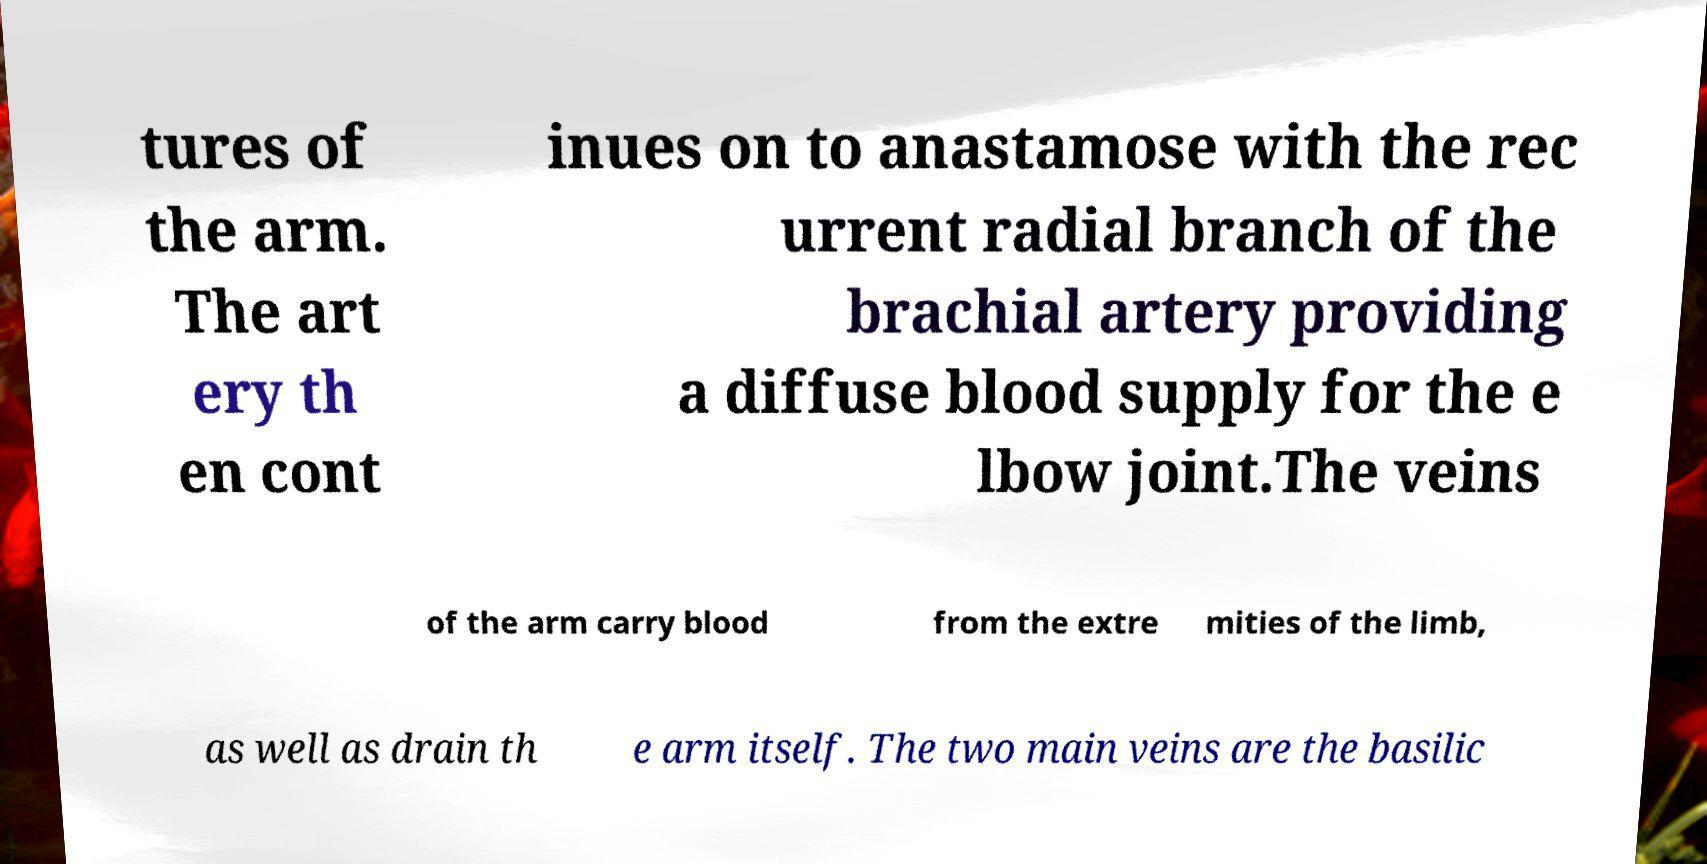Can you read and provide the text displayed in the image?This photo seems to have some interesting text. Can you extract and type it out for me? tures of the arm. The art ery th en cont inues on to anastamose with the rec urrent radial branch of the brachial artery providing a diffuse blood supply for the e lbow joint.The veins of the arm carry blood from the extre mities of the limb, as well as drain th e arm itself. The two main veins are the basilic 